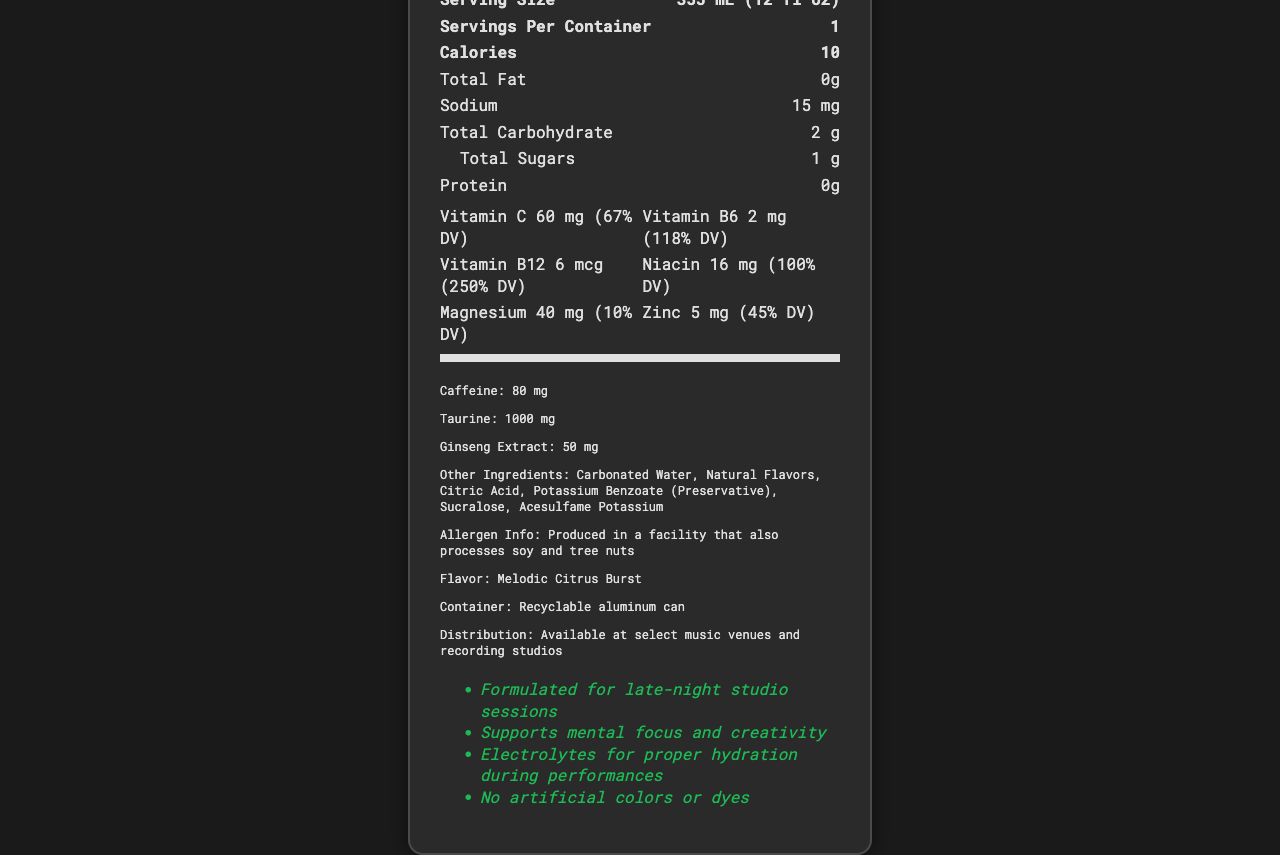what is the serving size? The document clearly states the serving size as "355 mL (12 fl oz)".
Answer: 355 mL (12 fl oz) how many calories are there per serving? The document mentions that each serving contains 10 calories.
Answer: 10 calories how much sodium does Sonic Hydration contain per serving? The sodium content per serving is listed as "15 mg" in the document.
Answer: 15 mg what is the amount of total carbohydrate in Sonic Hydration? The document specifies the total carbohydrate content as "2 g".
Answer: 2 g which vitamin has the highest daily value percentage in Sonic Hydration? The document states that Vitamin B12 has a daily value percentage of 250%, which is the highest among the listed vitamins.
Answer: Vitamin B12 how much caffeine is in one serving of Sonic Hydration? The caffeine content per serving is noted as "80 mg" in the document.
Answer: 80 mg what are the primary ingredients in Sonic Hydration? The document lists these as the primary ingredients in the "Other Ingredients" section.
Answer: Carbonated Water, Natural Flavors, Citric Acid, Potassium Benzoate (Preservative), Sucralose, Acesulfame Potassium what are the marketed benefits of Sonic Hydration? These benefits are listed under the "Marketing Claims" section of the document.
Answer: Formulated for late-night studio sessions, supports mental focus and creativity, electrolytes for proper hydration during performances, no artificial colors or dyes where can Sonic Hydration be purchased? The distribution information in the document states that the product is available at select music venues and recording studios.
Answer: Select music venues and recording studios what flavor is Sonic Hydration marketed as? A. Melodic Mango B. Harmonic Berry Blend C. Rhythmic Blueberry D. Melodic Citrus Burst The document lists the flavor as "Melodic Citrus Burst."
Answer: D how much Vitamin C does one serving of Sonic Hydration provide? A. 30 mg B. 60 mg C. 90 mg D. 120 mg The document specifies the Vitamin C content as "60 mg (67% DV)".
Answer: B is Sonic Hydration produced in a facility that processes allergens? A. Yes B. No C. Not mentioned The document includes allergen information stating it is produced in a facility that also processes soy and tree nuts.
Answer: A does Sonic Hydration contain protein? The document clearly states that the protein content is 0g per serving.
Answer: No what is the main idea of the Sonic Hydration nutrition facts document? This includes ingredients, nutritional values, marketing claims, flavor information, and distribution details.
Answer: The document provides detailed nutritional information and marketing claims for Sonic Hydration, a vitamin-enhanced sparkling water targeted at musicians. what is the country of manufacture for Sonic Hydration? The document does not provide any information about the country of manufacture.
Answer: Cannot be determined 